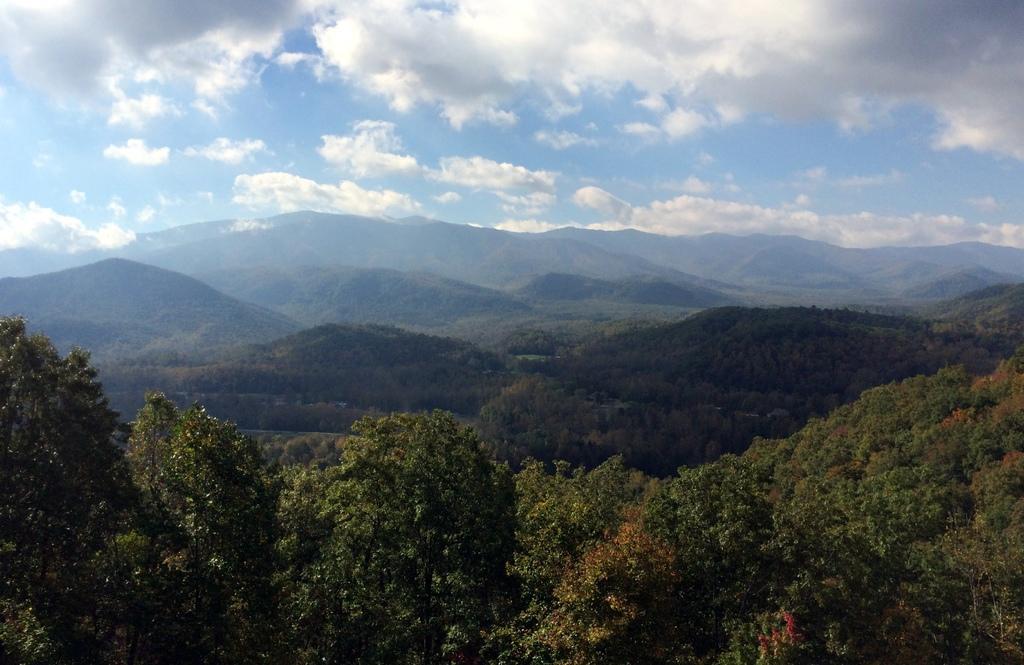Can you describe this image briefly? In this picture we can see trees, hills and sky with clouds. 